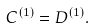<formula> <loc_0><loc_0><loc_500><loc_500>C ^ { ( 1 ) } = D ^ { ( 1 ) } .</formula> 